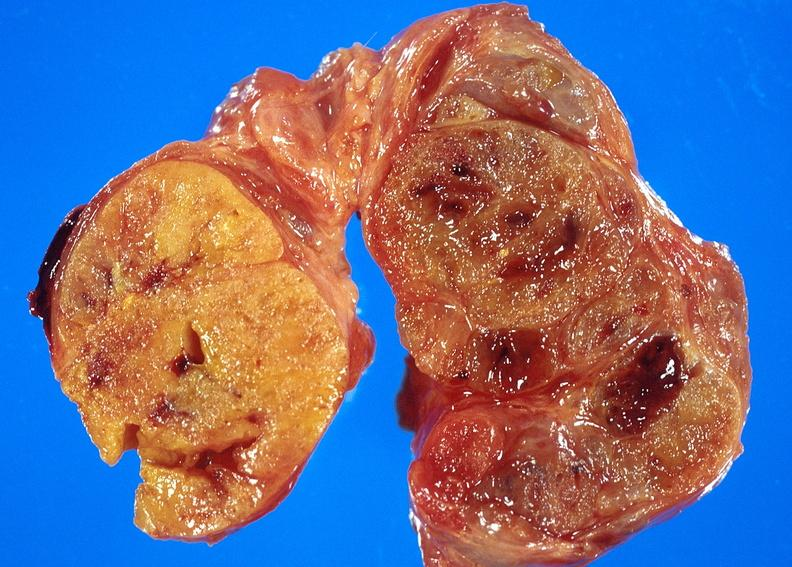does this image show thyroid, goiter?
Answer the question using a single word or phrase. Yes 